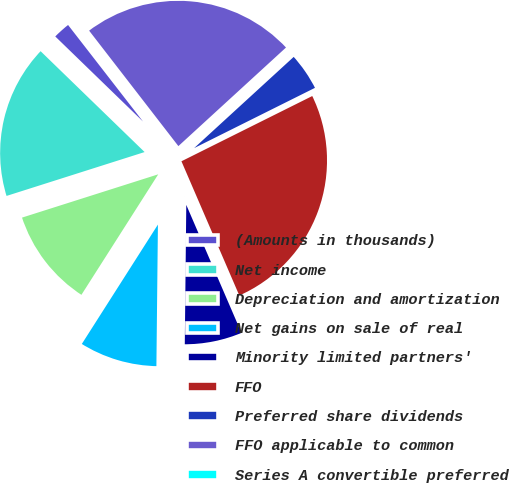Convert chart to OTSL. <chart><loc_0><loc_0><loc_500><loc_500><pie_chart><fcel>(Amounts in thousands)<fcel>Net income<fcel>Depreciation and amortization<fcel>Net gains on sale of real<fcel>Minority limited partners'<fcel>FFO<fcel>Preferred share dividends<fcel>FFO applicable to common<fcel>Series A convertible preferred<nl><fcel>2.24%<fcel>17.15%<fcel>11.07%<fcel>8.86%<fcel>6.65%<fcel>25.88%<fcel>4.44%<fcel>23.67%<fcel>0.03%<nl></chart> 